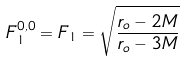<formula> <loc_0><loc_0><loc_500><loc_500>F _ { 1 } ^ { 0 , 0 } = F _ { 1 } = \sqrt { \frac { r _ { o } - 2 M } { r _ { o } - 3 M } }</formula> 